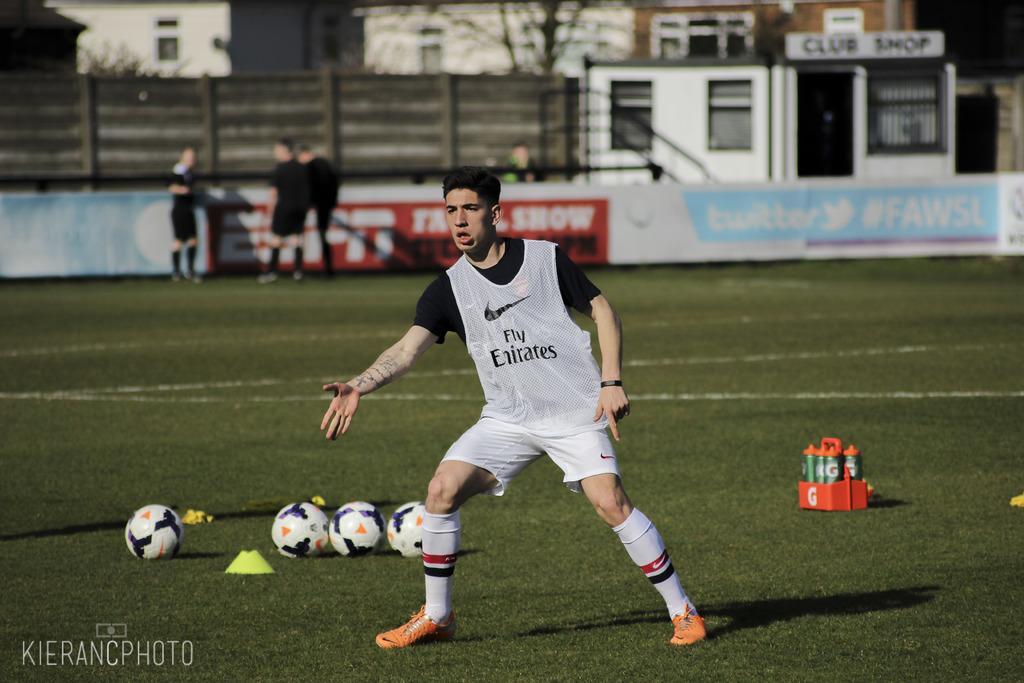How would you summarize this image in a sentence or two? In the image in the center we can see few balls,cans,basket,yellow color object and one person standing. And on the left bottom,there is a watermark. In the background we can see buildings,wall,windows,fence,banners and few people were standing. 